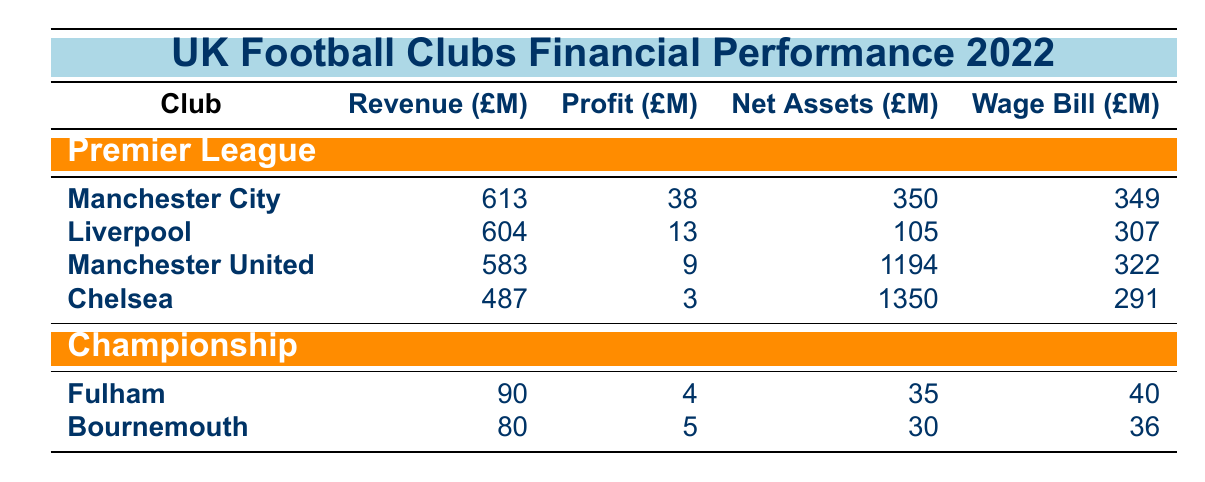What is the revenue of Manchester City? The revenue for Manchester City is listed directly in the table under the "Premier League" section. It shows 613 Million.
Answer: 613 Million Which club has the highest net assets? By comparing the net assets listed for each club in the Premier League, Manchester United has the highest net assets at 1194 Million, as seen in the table.
Answer: Manchester United What is the total revenue of clubs in the Championship? To find the total revenue of the Championship clubs, we add the revenues of Fulham (90 Million) and Bournemouth (80 Million), which equals 170 Million.
Answer: 170 Million Is Chelsea's profit before tax higher than that of Liverpool? The profit before tax for Chelsea is 3 Million, and for Liverpool, it is 13 Million. Since 3 Million is less than 13 Million, the statement is false.
Answer: No What is the average wage bill of the Premier League clubs? To find the average wage bill, we first sum the wage bills of all Premier League clubs: (349 + 307 + 322 + 291) = 1269 Million. There are 4 clubs, so the average wage bill is 1269 Million divided by 4, which is approximately 317.25 Million.
Answer: 317.25 Million Which club has the lowest profit before tax in the Premier League? By examining the profit figures in the Premier League section, we see Chelsea at 3 Million has the lowest profit before tax compared to other clubs.
Answer: Chelsea How much higher is Liverpool's revenue compared to Bournemouth's? Liverpool's revenue is 604 Million, while Bournemouth's revenue is 80 Million. The difference is calculated as 604 - 80 = 524 Million.
Answer: 524 Million Which club spends more on wages, Manchester City or Fulham? Manchester City has a wage bill of 349 Million, while Fulham has a wage bill of 40 Million. Since 349 Million is much higher than 40 Million, Manchester City spends more on wages.
Answer: Manchester City 